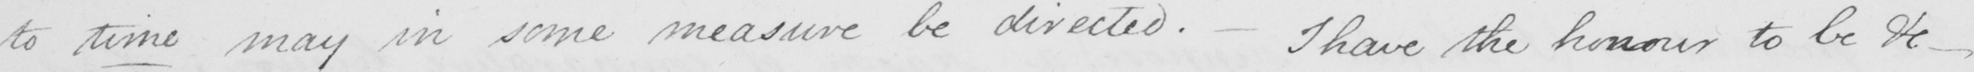Can you tell me what this handwritten text says? to time may in some measure be directed .  _  I have the honour to be &c  _ 